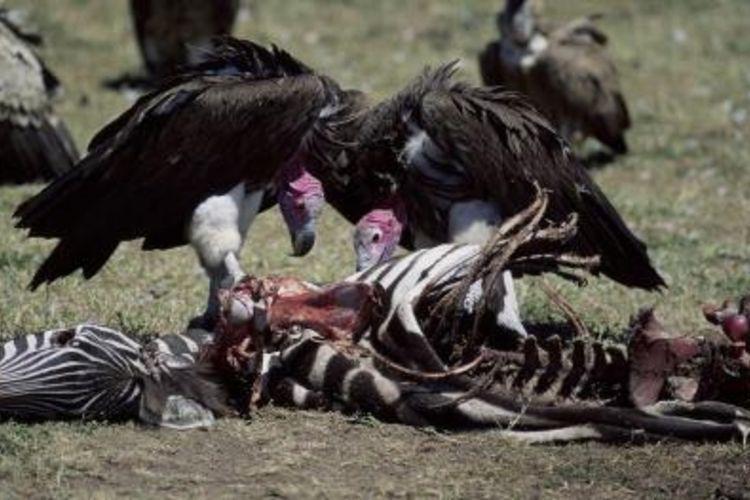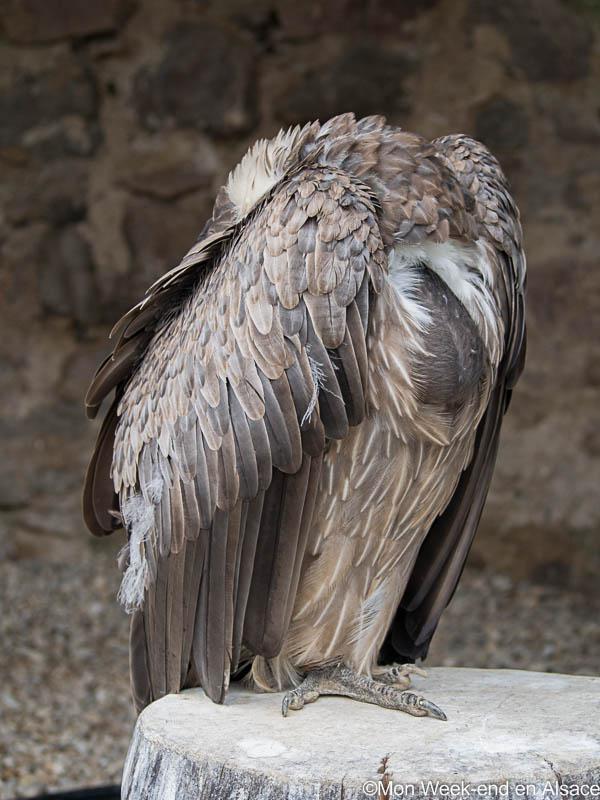The first image is the image on the left, the second image is the image on the right. Assess this claim about the two images: "An image shows vultures next to a zebra carcass.". Correct or not? Answer yes or no. Yes. The first image is the image on the left, the second image is the image on the right. For the images shown, is this caption "A single bird is standing on a stump in the image on the right." true? Answer yes or no. Yes. 